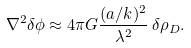Convert formula to latex. <formula><loc_0><loc_0><loc_500><loc_500>\nabla ^ { 2 } \delta \phi \approx 4 \pi G \frac { ( a / k ) ^ { 2 } } { \lambda ^ { 2 } } \, \delta \rho _ { D } .</formula> 